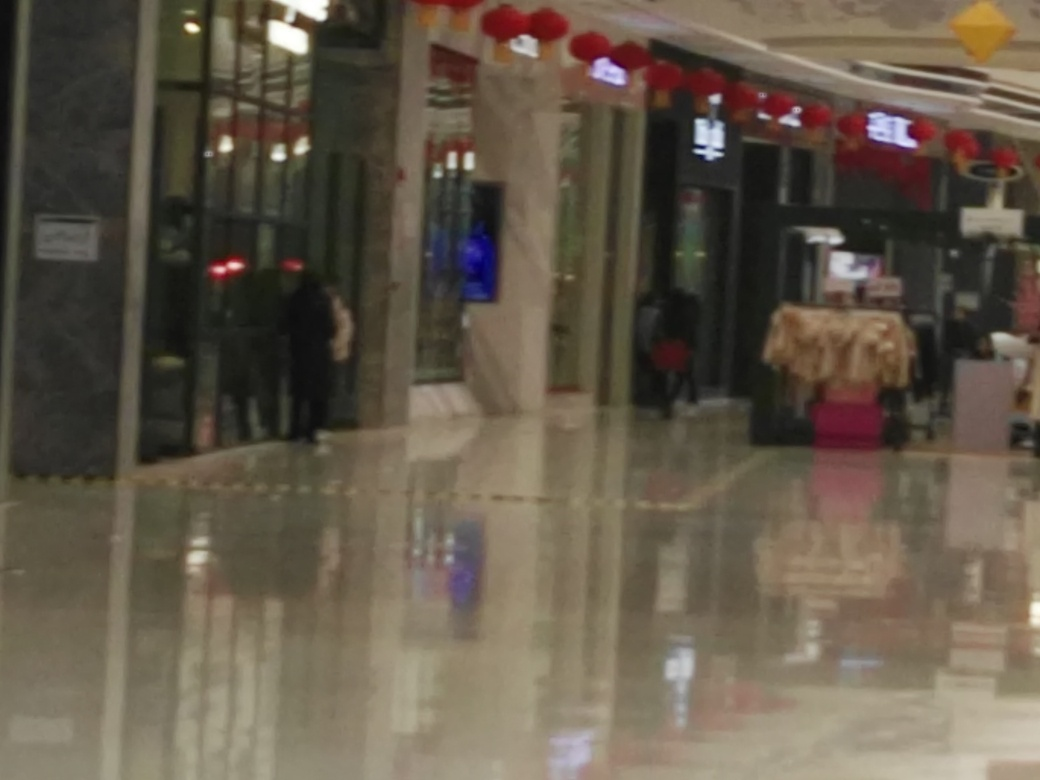What is the problem with the image quality?
A. The image has focusing problems and appears blurry.
B. The image has no focusing problems and is clear.
C. The image has exposure problems and appears overexposed. The main issue with the image quality is that it appears to have focusing problems, resulting in a blurry and unclear appearance. This can be due to several factors, such as camera movement, incorrect camera settings, or a subject that moved during the capture process. To improve such an image, one would need to use either a steadier hand when taking the photo, a tripod, or adjust the focus settings on the camera to ensure a sharp image. 